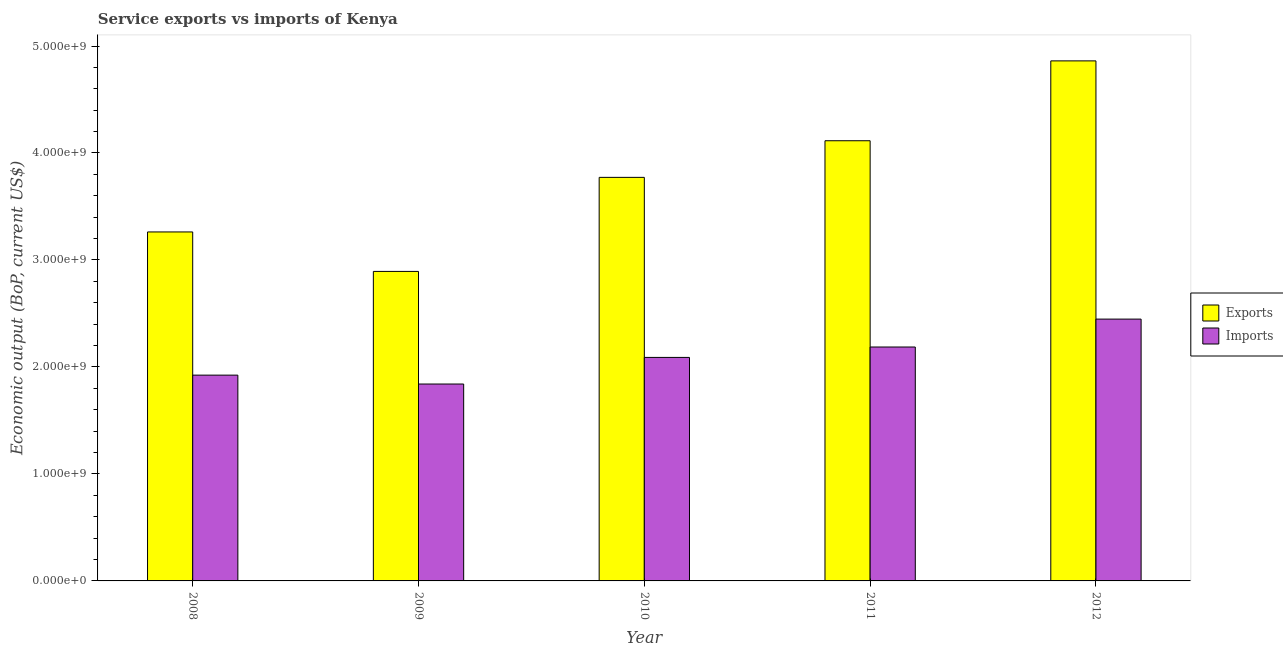How many different coloured bars are there?
Keep it short and to the point. 2. How many groups of bars are there?
Make the answer very short. 5. Are the number of bars on each tick of the X-axis equal?
Your response must be concise. Yes. What is the label of the 5th group of bars from the left?
Keep it short and to the point. 2012. What is the amount of service imports in 2008?
Give a very brief answer. 1.92e+09. Across all years, what is the maximum amount of service imports?
Provide a short and direct response. 2.45e+09. Across all years, what is the minimum amount of service exports?
Offer a terse response. 2.89e+09. In which year was the amount of service exports minimum?
Give a very brief answer. 2009. What is the total amount of service imports in the graph?
Your response must be concise. 1.05e+1. What is the difference between the amount of service exports in 2009 and that in 2010?
Your answer should be very brief. -8.79e+08. What is the difference between the amount of service exports in 2008 and the amount of service imports in 2010?
Your answer should be very brief. -5.10e+08. What is the average amount of service exports per year?
Offer a terse response. 3.78e+09. In the year 2012, what is the difference between the amount of service imports and amount of service exports?
Your response must be concise. 0. What is the ratio of the amount of service exports in 2010 to that in 2012?
Your answer should be very brief. 0.78. Is the amount of service exports in 2010 less than that in 2012?
Your answer should be compact. Yes. What is the difference between the highest and the second highest amount of service imports?
Give a very brief answer. 2.61e+08. What is the difference between the highest and the lowest amount of service exports?
Provide a short and direct response. 1.97e+09. In how many years, is the amount of service exports greater than the average amount of service exports taken over all years?
Keep it short and to the point. 2. Is the sum of the amount of service exports in 2010 and 2011 greater than the maximum amount of service imports across all years?
Offer a very short reply. Yes. What does the 1st bar from the left in 2011 represents?
Provide a succinct answer. Exports. What does the 2nd bar from the right in 2009 represents?
Make the answer very short. Exports. Are all the bars in the graph horizontal?
Offer a terse response. No. How many years are there in the graph?
Your answer should be compact. 5. Are the values on the major ticks of Y-axis written in scientific E-notation?
Ensure brevity in your answer.  Yes. Does the graph contain any zero values?
Offer a very short reply. No. Where does the legend appear in the graph?
Offer a very short reply. Center right. What is the title of the graph?
Your answer should be compact. Service exports vs imports of Kenya. Does "Working capital" appear as one of the legend labels in the graph?
Offer a terse response. No. What is the label or title of the Y-axis?
Ensure brevity in your answer.  Economic output (BoP, current US$). What is the Economic output (BoP, current US$) of Exports in 2008?
Provide a short and direct response. 3.26e+09. What is the Economic output (BoP, current US$) of Imports in 2008?
Provide a succinct answer. 1.92e+09. What is the Economic output (BoP, current US$) in Exports in 2009?
Ensure brevity in your answer.  2.89e+09. What is the Economic output (BoP, current US$) of Imports in 2009?
Offer a terse response. 1.84e+09. What is the Economic output (BoP, current US$) of Exports in 2010?
Keep it short and to the point. 3.77e+09. What is the Economic output (BoP, current US$) of Imports in 2010?
Keep it short and to the point. 2.09e+09. What is the Economic output (BoP, current US$) of Exports in 2011?
Offer a very short reply. 4.11e+09. What is the Economic output (BoP, current US$) in Imports in 2011?
Ensure brevity in your answer.  2.19e+09. What is the Economic output (BoP, current US$) of Exports in 2012?
Your answer should be compact. 4.86e+09. What is the Economic output (BoP, current US$) of Imports in 2012?
Provide a short and direct response. 2.45e+09. Across all years, what is the maximum Economic output (BoP, current US$) in Exports?
Your answer should be compact. 4.86e+09. Across all years, what is the maximum Economic output (BoP, current US$) in Imports?
Make the answer very short. 2.45e+09. Across all years, what is the minimum Economic output (BoP, current US$) in Exports?
Ensure brevity in your answer.  2.89e+09. Across all years, what is the minimum Economic output (BoP, current US$) in Imports?
Provide a succinct answer. 1.84e+09. What is the total Economic output (BoP, current US$) in Exports in the graph?
Provide a succinct answer. 1.89e+1. What is the total Economic output (BoP, current US$) in Imports in the graph?
Give a very brief answer. 1.05e+1. What is the difference between the Economic output (BoP, current US$) in Exports in 2008 and that in 2009?
Offer a very short reply. 3.69e+08. What is the difference between the Economic output (BoP, current US$) in Imports in 2008 and that in 2009?
Offer a very short reply. 8.31e+07. What is the difference between the Economic output (BoP, current US$) of Exports in 2008 and that in 2010?
Your response must be concise. -5.10e+08. What is the difference between the Economic output (BoP, current US$) of Imports in 2008 and that in 2010?
Keep it short and to the point. -1.66e+08. What is the difference between the Economic output (BoP, current US$) of Exports in 2008 and that in 2011?
Keep it short and to the point. -8.53e+08. What is the difference between the Economic output (BoP, current US$) of Imports in 2008 and that in 2011?
Your response must be concise. -2.63e+08. What is the difference between the Economic output (BoP, current US$) of Exports in 2008 and that in 2012?
Your answer should be very brief. -1.60e+09. What is the difference between the Economic output (BoP, current US$) in Imports in 2008 and that in 2012?
Make the answer very short. -5.24e+08. What is the difference between the Economic output (BoP, current US$) of Exports in 2009 and that in 2010?
Keep it short and to the point. -8.79e+08. What is the difference between the Economic output (BoP, current US$) in Imports in 2009 and that in 2010?
Ensure brevity in your answer.  -2.49e+08. What is the difference between the Economic output (BoP, current US$) of Exports in 2009 and that in 2011?
Ensure brevity in your answer.  -1.22e+09. What is the difference between the Economic output (BoP, current US$) of Imports in 2009 and that in 2011?
Make the answer very short. -3.46e+08. What is the difference between the Economic output (BoP, current US$) of Exports in 2009 and that in 2012?
Keep it short and to the point. -1.97e+09. What is the difference between the Economic output (BoP, current US$) in Imports in 2009 and that in 2012?
Your answer should be very brief. -6.07e+08. What is the difference between the Economic output (BoP, current US$) in Exports in 2010 and that in 2011?
Provide a short and direct response. -3.42e+08. What is the difference between the Economic output (BoP, current US$) of Imports in 2010 and that in 2011?
Offer a terse response. -9.74e+07. What is the difference between the Economic output (BoP, current US$) in Exports in 2010 and that in 2012?
Provide a succinct answer. -1.09e+09. What is the difference between the Economic output (BoP, current US$) in Imports in 2010 and that in 2012?
Give a very brief answer. -3.58e+08. What is the difference between the Economic output (BoP, current US$) of Exports in 2011 and that in 2012?
Your response must be concise. -7.46e+08. What is the difference between the Economic output (BoP, current US$) of Imports in 2011 and that in 2012?
Your answer should be compact. -2.61e+08. What is the difference between the Economic output (BoP, current US$) in Exports in 2008 and the Economic output (BoP, current US$) in Imports in 2009?
Your answer should be compact. 1.42e+09. What is the difference between the Economic output (BoP, current US$) of Exports in 2008 and the Economic output (BoP, current US$) of Imports in 2010?
Provide a short and direct response. 1.17e+09. What is the difference between the Economic output (BoP, current US$) of Exports in 2008 and the Economic output (BoP, current US$) of Imports in 2011?
Your answer should be very brief. 1.08e+09. What is the difference between the Economic output (BoP, current US$) in Exports in 2008 and the Economic output (BoP, current US$) in Imports in 2012?
Your answer should be compact. 8.15e+08. What is the difference between the Economic output (BoP, current US$) of Exports in 2009 and the Economic output (BoP, current US$) of Imports in 2010?
Provide a succinct answer. 8.04e+08. What is the difference between the Economic output (BoP, current US$) in Exports in 2009 and the Economic output (BoP, current US$) in Imports in 2011?
Keep it short and to the point. 7.07e+08. What is the difference between the Economic output (BoP, current US$) of Exports in 2009 and the Economic output (BoP, current US$) of Imports in 2012?
Give a very brief answer. 4.46e+08. What is the difference between the Economic output (BoP, current US$) in Exports in 2010 and the Economic output (BoP, current US$) in Imports in 2011?
Your response must be concise. 1.59e+09. What is the difference between the Economic output (BoP, current US$) of Exports in 2010 and the Economic output (BoP, current US$) of Imports in 2012?
Ensure brevity in your answer.  1.32e+09. What is the difference between the Economic output (BoP, current US$) in Exports in 2011 and the Economic output (BoP, current US$) in Imports in 2012?
Provide a succinct answer. 1.67e+09. What is the average Economic output (BoP, current US$) in Exports per year?
Make the answer very short. 3.78e+09. What is the average Economic output (BoP, current US$) in Imports per year?
Give a very brief answer. 2.10e+09. In the year 2008, what is the difference between the Economic output (BoP, current US$) in Exports and Economic output (BoP, current US$) in Imports?
Your answer should be very brief. 1.34e+09. In the year 2009, what is the difference between the Economic output (BoP, current US$) in Exports and Economic output (BoP, current US$) in Imports?
Provide a short and direct response. 1.05e+09. In the year 2010, what is the difference between the Economic output (BoP, current US$) in Exports and Economic output (BoP, current US$) in Imports?
Give a very brief answer. 1.68e+09. In the year 2011, what is the difference between the Economic output (BoP, current US$) of Exports and Economic output (BoP, current US$) of Imports?
Offer a very short reply. 1.93e+09. In the year 2012, what is the difference between the Economic output (BoP, current US$) in Exports and Economic output (BoP, current US$) in Imports?
Your response must be concise. 2.41e+09. What is the ratio of the Economic output (BoP, current US$) of Exports in 2008 to that in 2009?
Ensure brevity in your answer.  1.13. What is the ratio of the Economic output (BoP, current US$) in Imports in 2008 to that in 2009?
Your answer should be compact. 1.05. What is the ratio of the Economic output (BoP, current US$) of Exports in 2008 to that in 2010?
Keep it short and to the point. 0.86. What is the ratio of the Economic output (BoP, current US$) in Imports in 2008 to that in 2010?
Your response must be concise. 0.92. What is the ratio of the Economic output (BoP, current US$) of Exports in 2008 to that in 2011?
Make the answer very short. 0.79. What is the ratio of the Economic output (BoP, current US$) in Imports in 2008 to that in 2011?
Your answer should be compact. 0.88. What is the ratio of the Economic output (BoP, current US$) of Exports in 2008 to that in 2012?
Offer a terse response. 0.67. What is the ratio of the Economic output (BoP, current US$) in Imports in 2008 to that in 2012?
Make the answer very short. 0.79. What is the ratio of the Economic output (BoP, current US$) of Exports in 2009 to that in 2010?
Provide a succinct answer. 0.77. What is the ratio of the Economic output (BoP, current US$) in Imports in 2009 to that in 2010?
Your answer should be compact. 0.88. What is the ratio of the Economic output (BoP, current US$) of Exports in 2009 to that in 2011?
Give a very brief answer. 0.7. What is the ratio of the Economic output (BoP, current US$) in Imports in 2009 to that in 2011?
Provide a succinct answer. 0.84. What is the ratio of the Economic output (BoP, current US$) in Exports in 2009 to that in 2012?
Make the answer very short. 0.6. What is the ratio of the Economic output (BoP, current US$) of Imports in 2009 to that in 2012?
Make the answer very short. 0.75. What is the ratio of the Economic output (BoP, current US$) in Exports in 2010 to that in 2011?
Give a very brief answer. 0.92. What is the ratio of the Economic output (BoP, current US$) of Imports in 2010 to that in 2011?
Offer a very short reply. 0.96. What is the ratio of the Economic output (BoP, current US$) in Exports in 2010 to that in 2012?
Offer a terse response. 0.78. What is the ratio of the Economic output (BoP, current US$) in Imports in 2010 to that in 2012?
Offer a terse response. 0.85. What is the ratio of the Economic output (BoP, current US$) of Exports in 2011 to that in 2012?
Make the answer very short. 0.85. What is the ratio of the Economic output (BoP, current US$) of Imports in 2011 to that in 2012?
Offer a terse response. 0.89. What is the difference between the highest and the second highest Economic output (BoP, current US$) of Exports?
Ensure brevity in your answer.  7.46e+08. What is the difference between the highest and the second highest Economic output (BoP, current US$) of Imports?
Ensure brevity in your answer.  2.61e+08. What is the difference between the highest and the lowest Economic output (BoP, current US$) in Exports?
Offer a terse response. 1.97e+09. What is the difference between the highest and the lowest Economic output (BoP, current US$) in Imports?
Provide a short and direct response. 6.07e+08. 